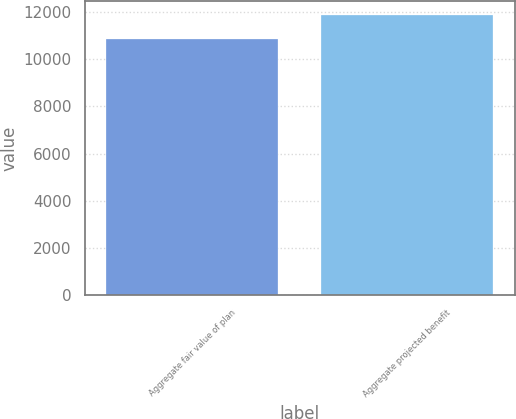Convert chart. <chart><loc_0><loc_0><loc_500><loc_500><bar_chart><fcel>Aggregate fair value of plan<fcel>Aggregate projected benefit<nl><fcel>10866<fcel>11866<nl></chart> 